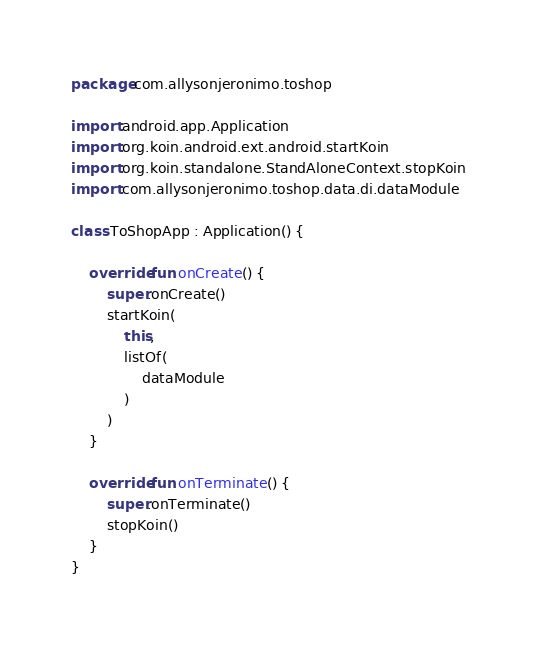<code> <loc_0><loc_0><loc_500><loc_500><_Kotlin_>package com.allysonjeronimo.toshop

import android.app.Application
import org.koin.android.ext.android.startKoin
import org.koin.standalone.StandAloneContext.stopKoin
import com.allysonjeronimo.toshop.data.di.dataModule

class ToShopApp : Application() {

    override fun onCreate() {
        super.onCreate()
        startKoin(
            this,
            listOf(
                dataModule
            )
        )
    }

    override fun onTerminate() {
        super.onTerminate()
        stopKoin()
    }
}</code> 